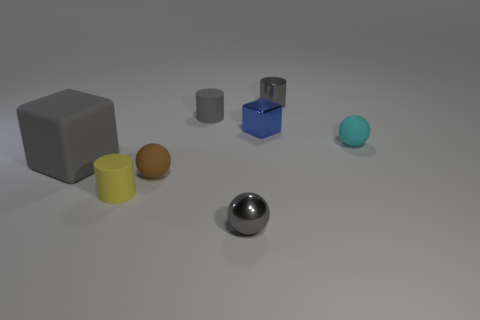Add 1 small brown rubber objects. How many objects exist? 9 Subtract all blocks. How many objects are left? 6 Add 3 big blue shiny cylinders. How many big blue shiny cylinders exist? 3 Subtract 0 purple cylinders. How many objects are left? 8 Subtract all yellow balls. Subtract all tiny gray rubber cylinders. How many objects are left? 7 Add 8 large things. How many large things are left? 9 